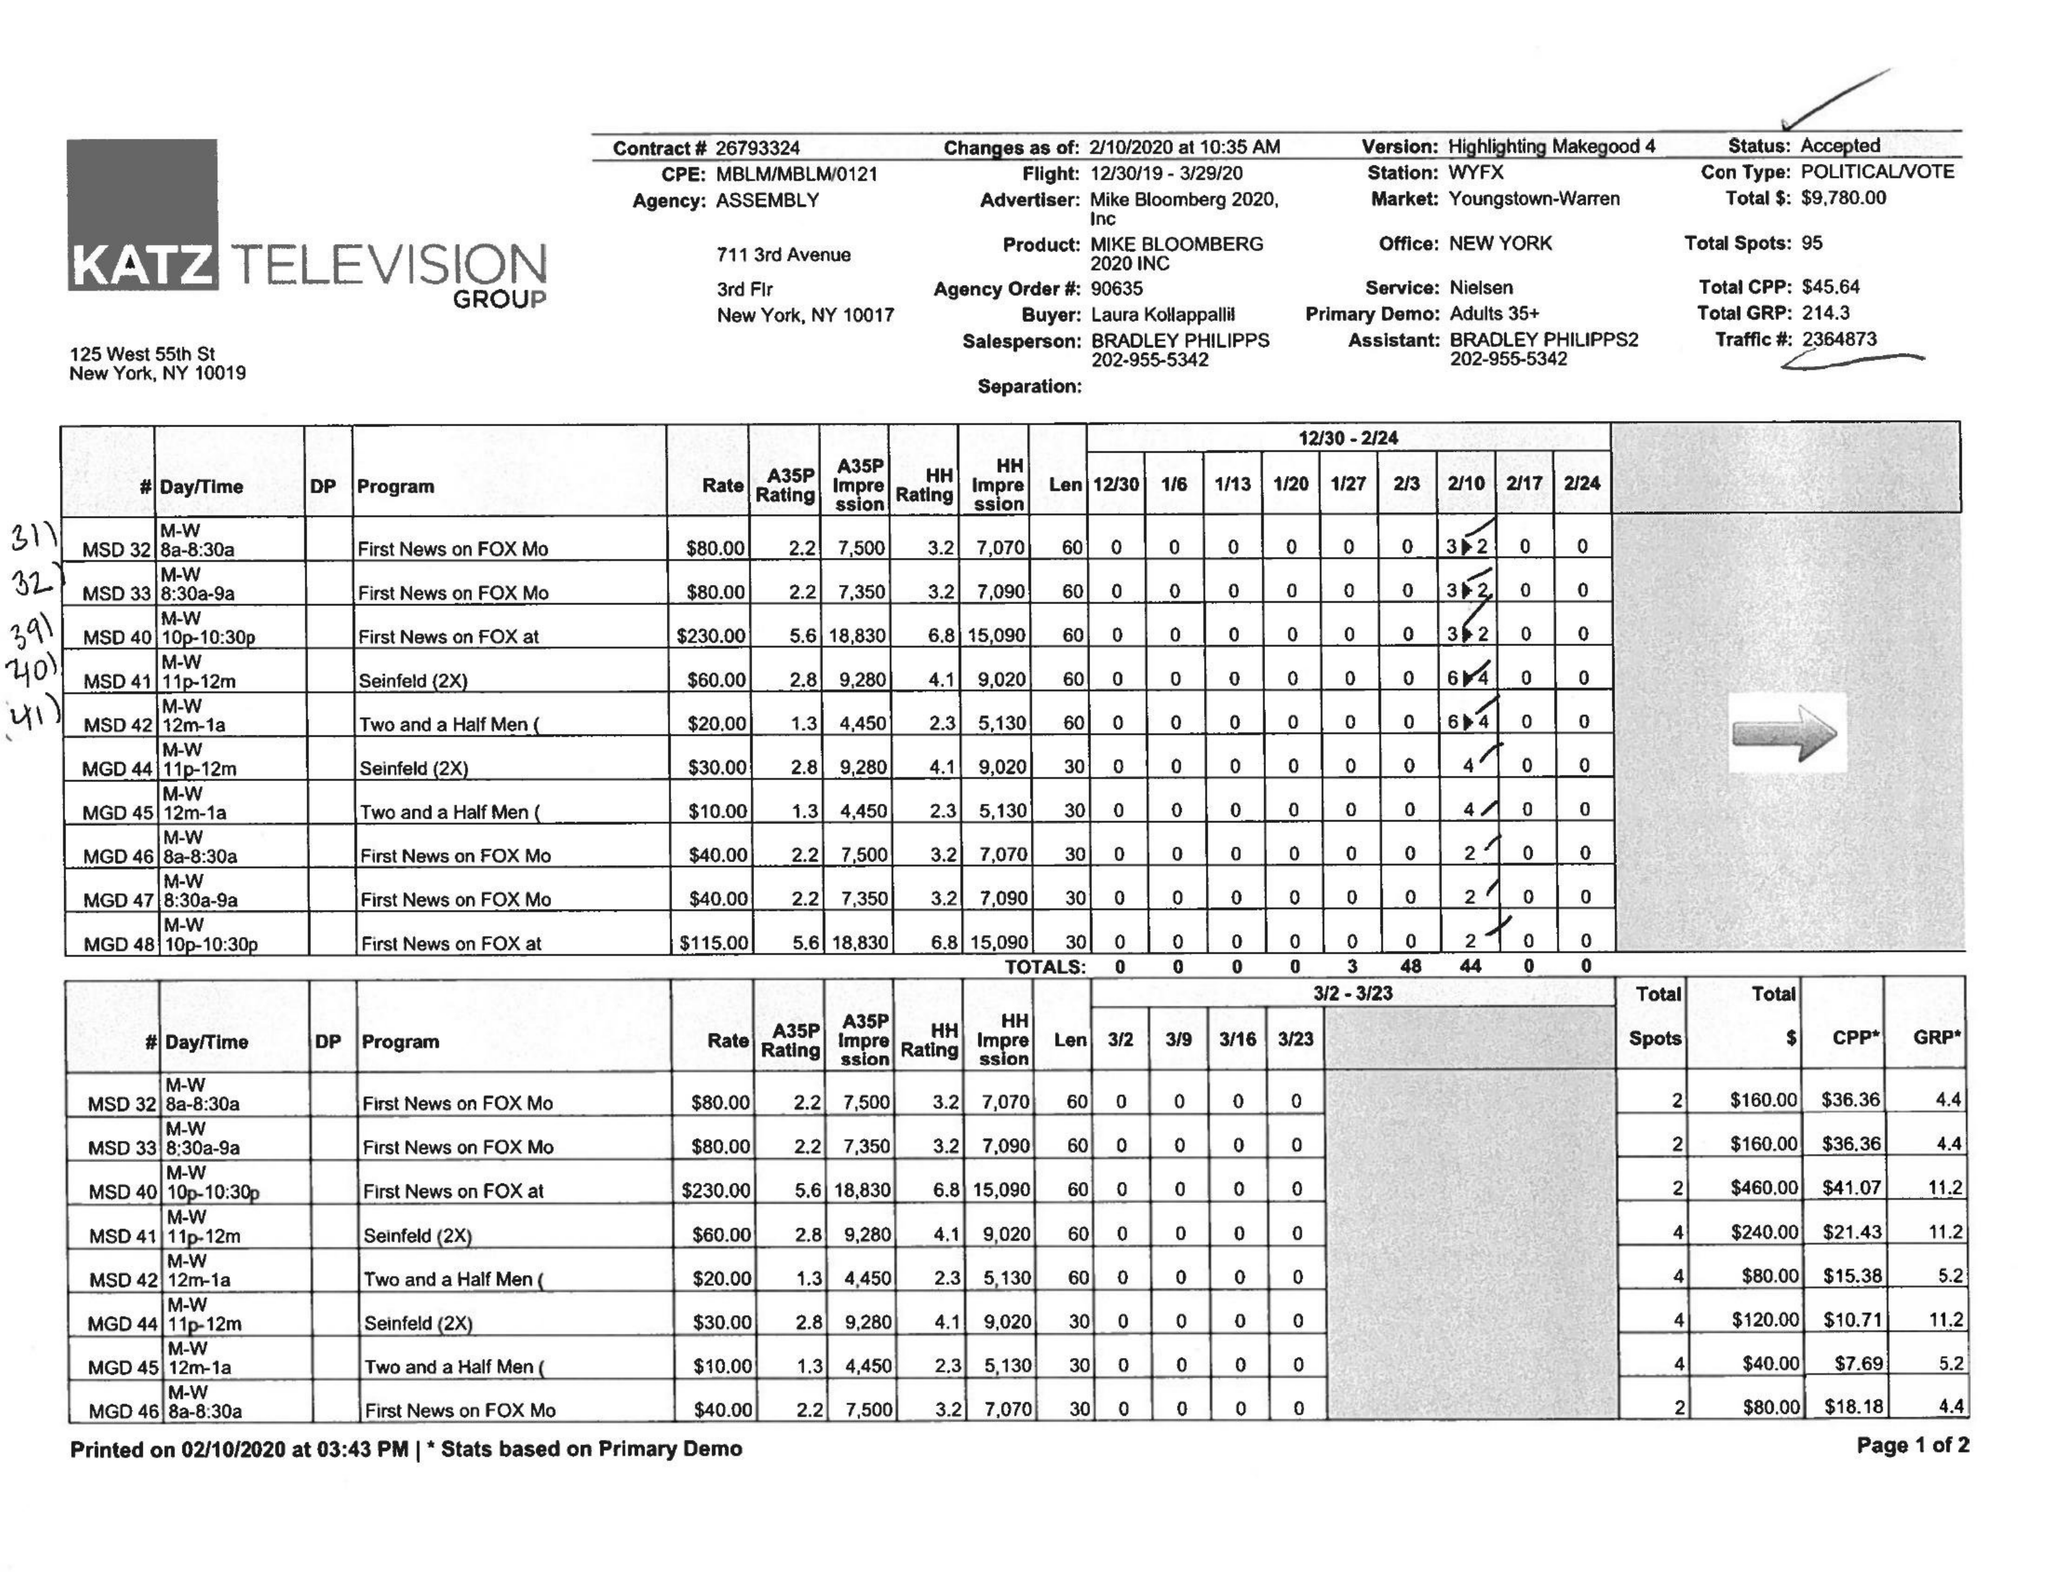What is the value for the flight_from?
Answer the question using a single word or phrase. 12/30/19 